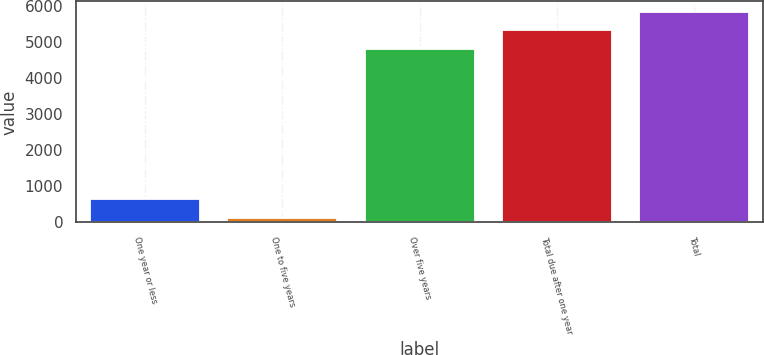<chart> <loc_0><loc_0><loc_500><loc_500><bar_chart><fcel>One year or less<fcel>One to five years<fcel>Over five years<fcel>Total due after one year<fcel>Total<nl><fcel>636.26<fcel>126.8<fcel>4822<fcel>5331.46<fcel>5840.92<nl></chart> 